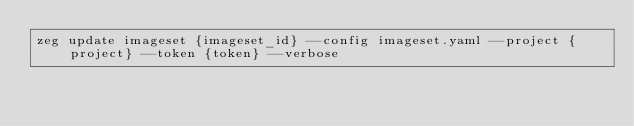Convert code to text. <code><loc_0><loc_0><loc_500><loc_500><_Bash_>zeg update imageset {imageset_id} --config imageset.yaml --project {project} --token {token} --verbose
</code> 